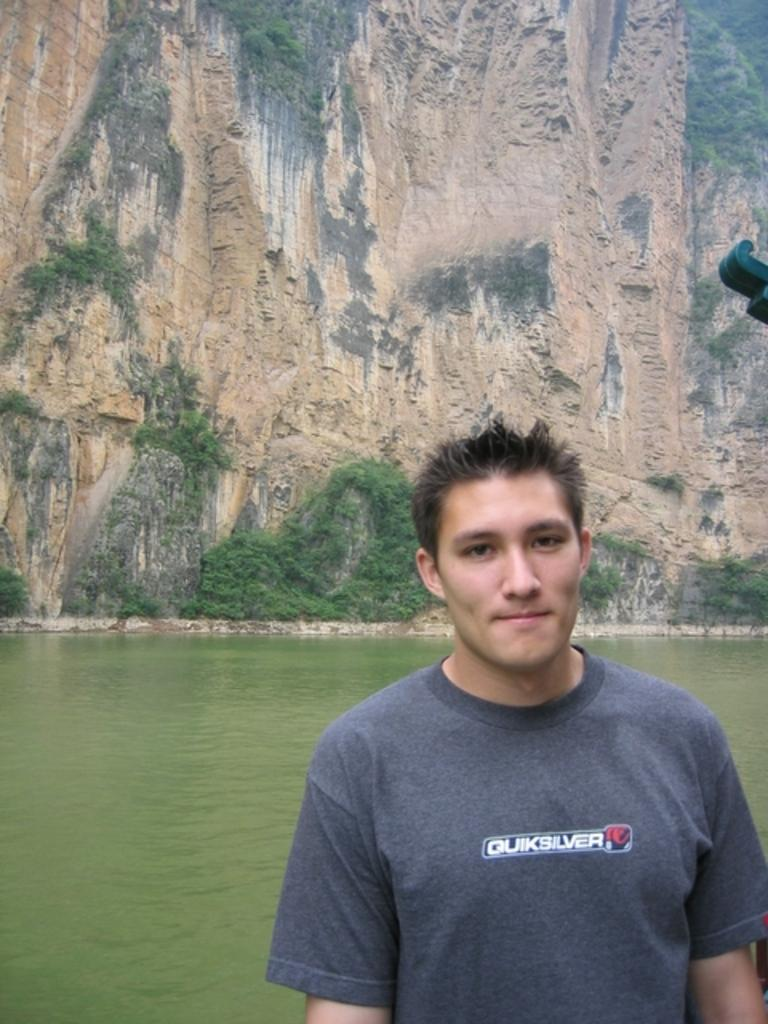What is the main subject of the image? There is a man standing in the image. What can be seen in the background of the image? There is a river in the background of the image. What is the prominent geographical feature in the image? There is a huge mountain in the image. What type of vegetation is present in the image? There are trees in the image. What type of plastic object can be seen rolling down the mountain in the image? There is no plastic object rolling down the mountain in the image. 